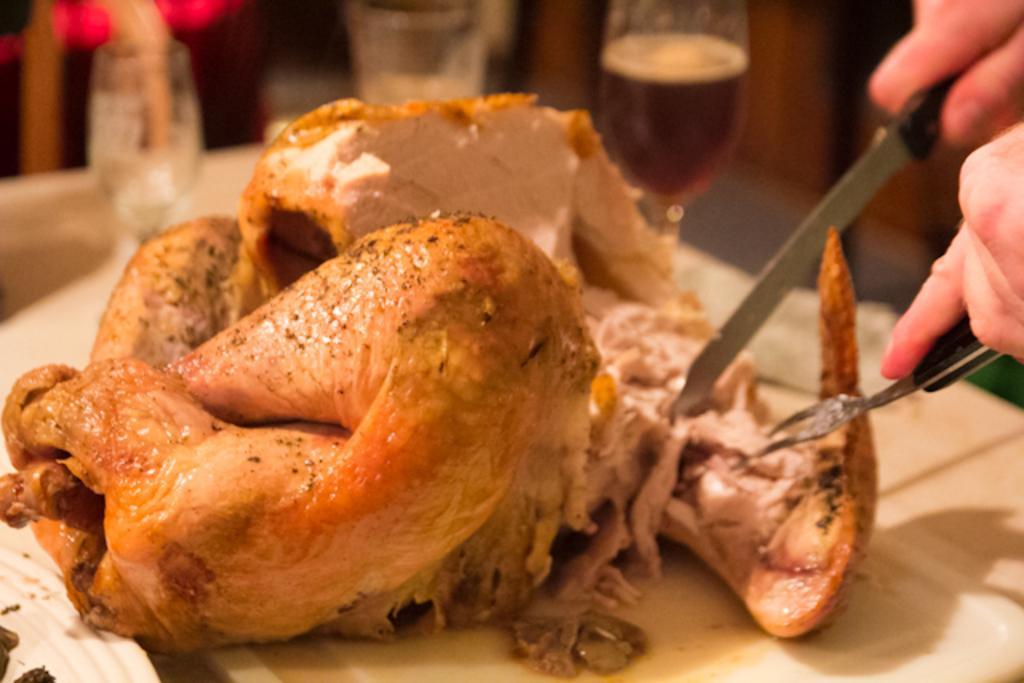Describe this image in one or two sentences. In this picture there is a grill chicken on the white color plate. On the right side there is a person hand with a knife and fork. Behind there is a wine glass and a blur background. 